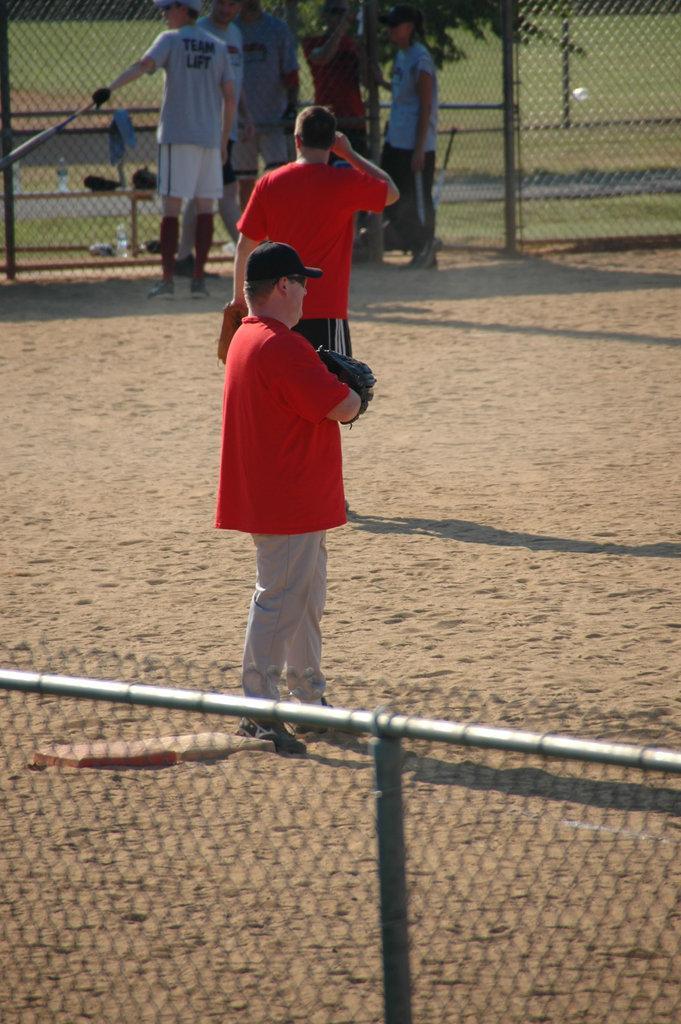Can you describe this image briefly? In this image I can observe few persons on the ground. I can see a tree. There is a fencing. In the background I can see some grass on the ground. 